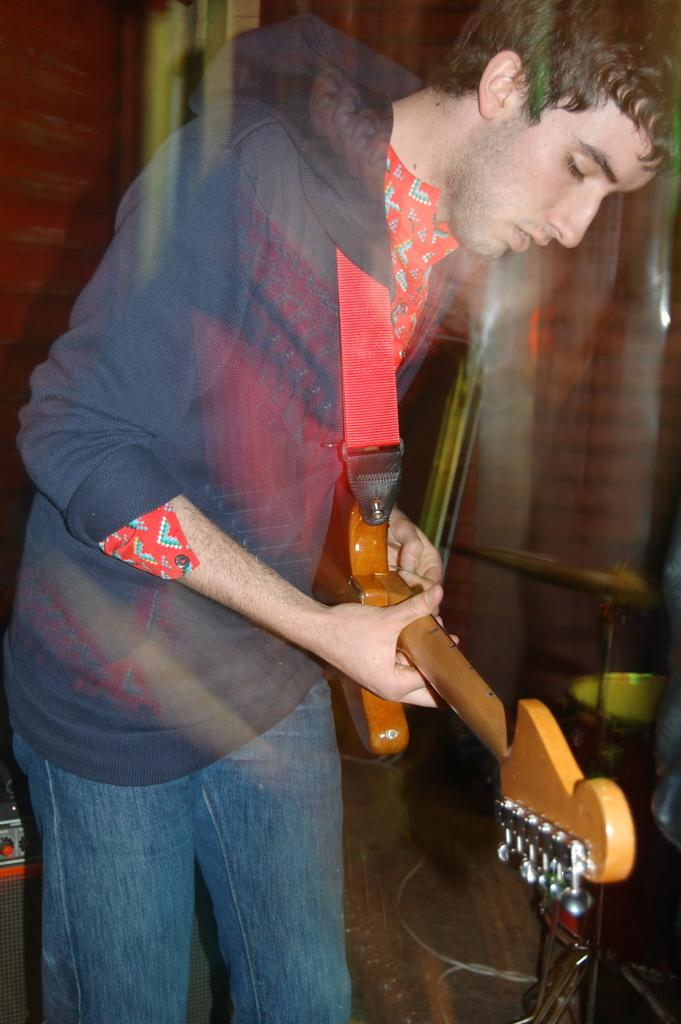What is the main subject of the image? The main subject of the image is a man. What is the man doing in the image? The man is playing a guitar in the image. Can you tell me when the man's birthday is in the image? There is no information about the man's birthday in the image. What type of knife is the man using to play the guitar in the image? There is no knife present in the image; the man is playing a guitar with his hands. 